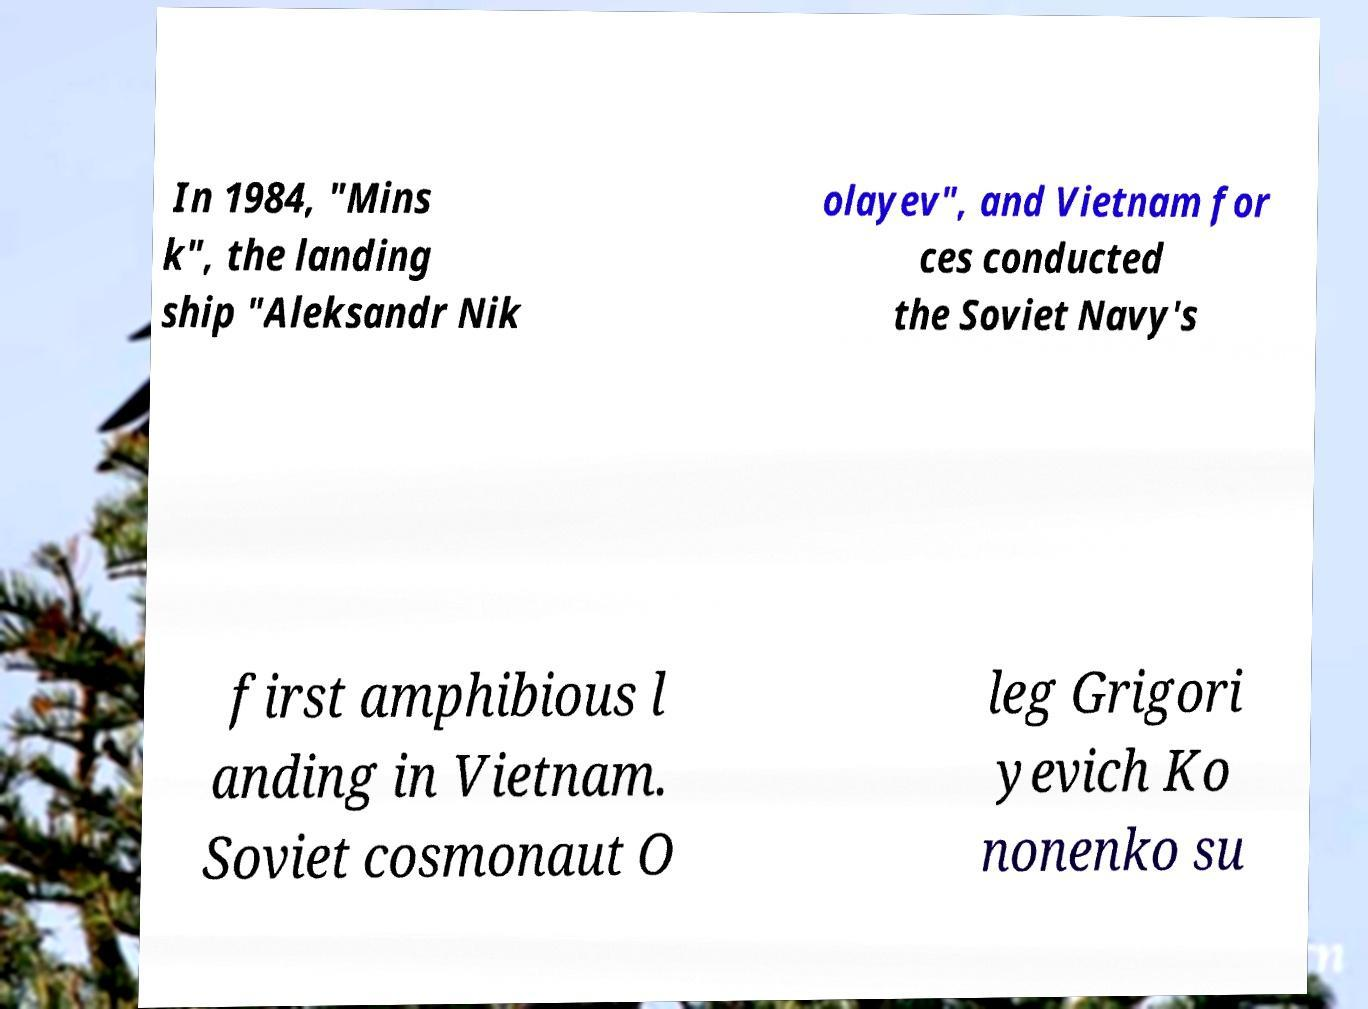Could you assist in decoding the text presented in this image and type it out clearly? In 1984, "Mins k", the landing ship "Aleksandr Nik olayev", and Vietnam for ces conducted the Soviet Navy's first amphibious l anding in Vietnam. Soviet cosmonaut O leg Grigori yevich Ko nonenko su 